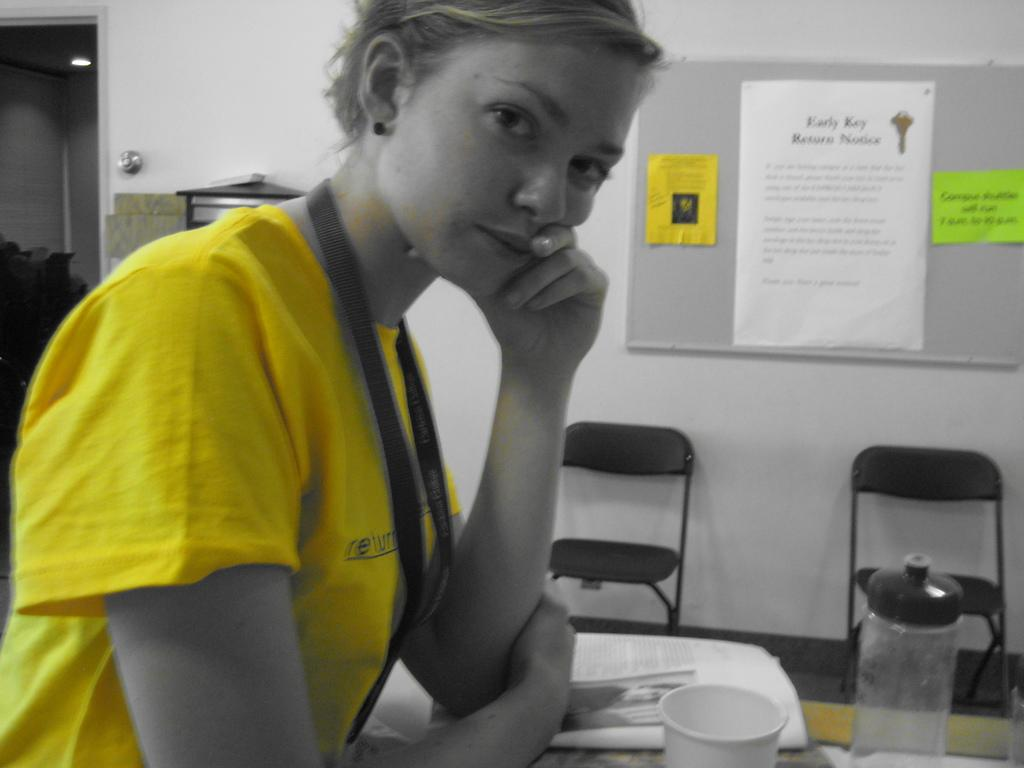Provide a one-sentence caption for the provided image. A woman wearing a yellow shirt standing in front of a bulletin board listing the early key return notice. 